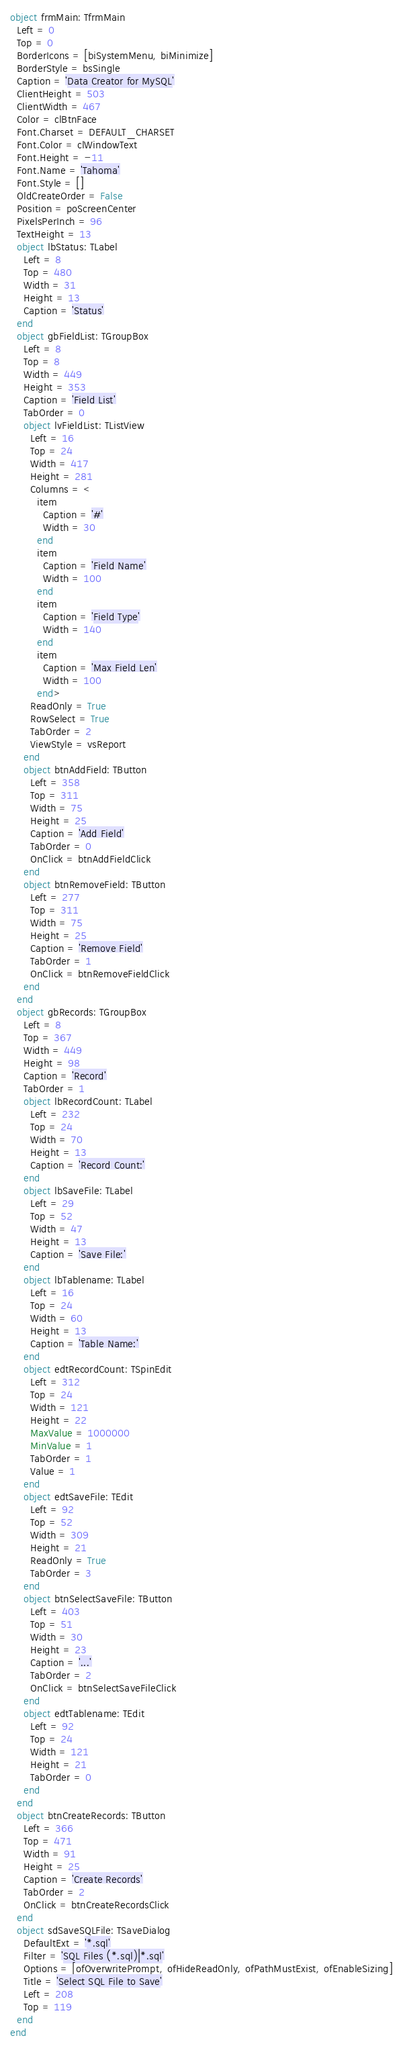Convert code to text. <code><loc_0><loc_0><loc_500><loc_500><_Pascal_>object frmMain: TfrmMain
  Left = 0
  Top = 0
  BorderIcons = [biSystemMenu, biMinimize]
  BorderStyle = bsSingle
  Caption = 'Data Creator for MySQL'
  ClientHeight = 503
  ClientWidth = 467
  Color = clBtnFace
  Font.Charset = DEFAULT_CHARSET
  Font.Color = clWindowText
  Font.Height = -11
  Font.Name = 'Tahoma'
  Font.Style = []
  OldCreateOrder = False
  Position = poScreenCenter
  PixelsPerInch = 96
  TextHeight = 13
  object lbStatus: TLabel
    Left = 8
    Top = 480
    Width = 31
    Height = 13
    Caption = 'Status'
  end
  object gbFieldList: TGroupBox
    Left = 8
    Top = 8
    Width = 449
    Height = 353
    Caption = 'Field List'
    TabOrder = 0
    object lvFieldList: TListView
      Left = 16
      Top = 24
      Width = 417
      Height = 281
      Columns = <
        item
          Caption = '#'
          Width = 30
        end
        item
          Caption = 'Field Name'
          Width = 100
        end
        item
          Caption = 'Field Type'
          Width = 140
        end
        item
          Caption = 'Max Field Len'
          Width = 100
        end>
      ReadOnly = True
      RowSelect = True
      TabOrder = 2
      ViewStyle = vsReport
    end
    object btnAddField: TButton
      Left = 358
      Top = 311
      Width = 75
      Height = 25
      Caption = 'Add Field'
      TabOrder = 0
      OnClick = btnAddFieldClick
    end
    object btnRemoveField: TButton
      Left = 277
      Top = 311
      Width = 75
      Height = 25
      Caption = 'Remove Field'
      TabOrder = 1
      OnClick = btnRemoveFieldClick
    end
  end
  object gbRecords: TGroupBox
    Left = 8
    Top = 367
    Width = 449
    Height = 98
    Caption = 'Record'
    TabOrder = 1
    object lbRecordCount: TLabel
      Left = 232
      Top = 24
      Width = 70
      Height = 13
      Caption = 'Record Count:'
    end
    object lbSaveFile: TLabel
      Left = 29
      Top = 52
      Width = 47
      Height = 13
      Caption = 'Save File:'
    end
    object lbTablename: TLabel
      Left = 16
      Top = 24
      Width = 60
      Height = 13
      Caption = 'Table Name:'
    end
    object edtRecordCount: TSpinEdit
      Left = 312
      Top = 24
      Width = 121
      Height = 22
      MaxValue = 1000000
      MinValue = 1
      TabOrder = 1
      Value = 1
    end
    object edtSaveFile: TEdit
      Left = 92
      Top = 52
      Width = 309
      Height = 21
      ReadOnly = True
      TabOrder = 3
    end
    object btnSelectSaveFile: TButton
      Left = 403
      Top = 51
      Width = 30
      Height = 23
      Caption = '...'
      TabOrder = 2
      OnClick = btnSelectSaveFileClick
    end
    object edtTablename: TEdit
      Left = 92
      Top = 24
      Width = 121
      Height = 21
      TabOrder = 0
    end
  end
  object btnCreateRecords: TButton
    Left = 366
    Top = 471
    Width = 91
    Height = 25
    Caption = 'Create Records'
    TabOrder = 2
    OnClick = btnCreateRecordsClick
  end
  object sdSaveSQLFile: TSaveDialog
    DefaultExt = '*.sql'
    Filter = 'SQL Files (*.sql)|*.sql'
    Options = [ofOverwritePrompt, ofHideReadOnly, ofPathMustExist, ofEnableSizing]
    Title = 'Select SQL File to Save'
    Left = 208
    Top = 119
  end
end
</code> 